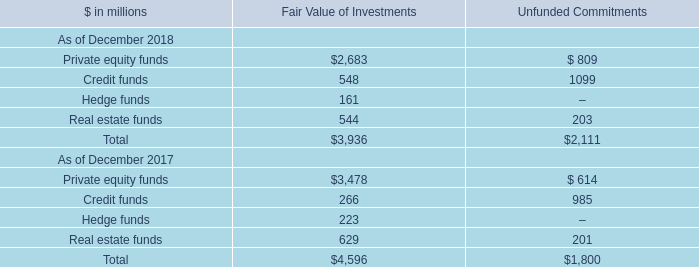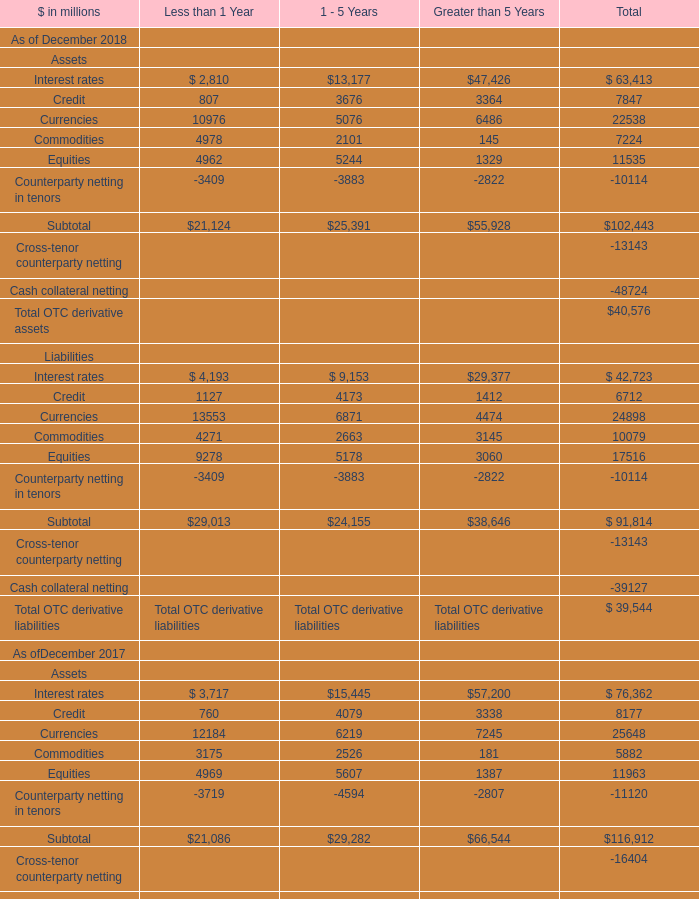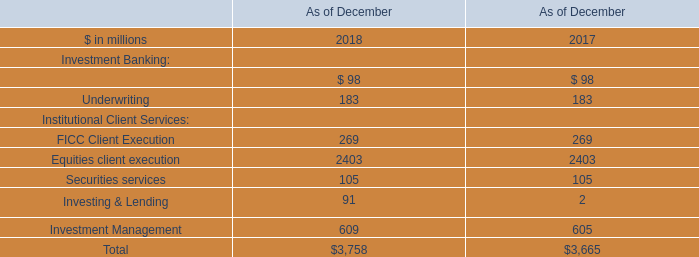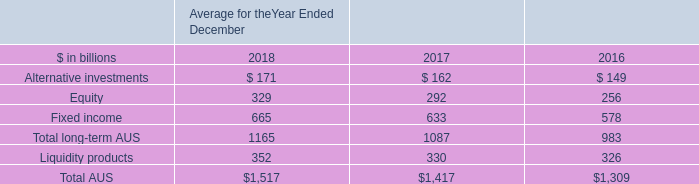What is the average amount of Credit funds of Unfunded Commitments, and Commodities Assets of Less than 1 Year ? 
Computations: ((1099.0 + 3175.0) / 2)
Answer: 2137.0. 